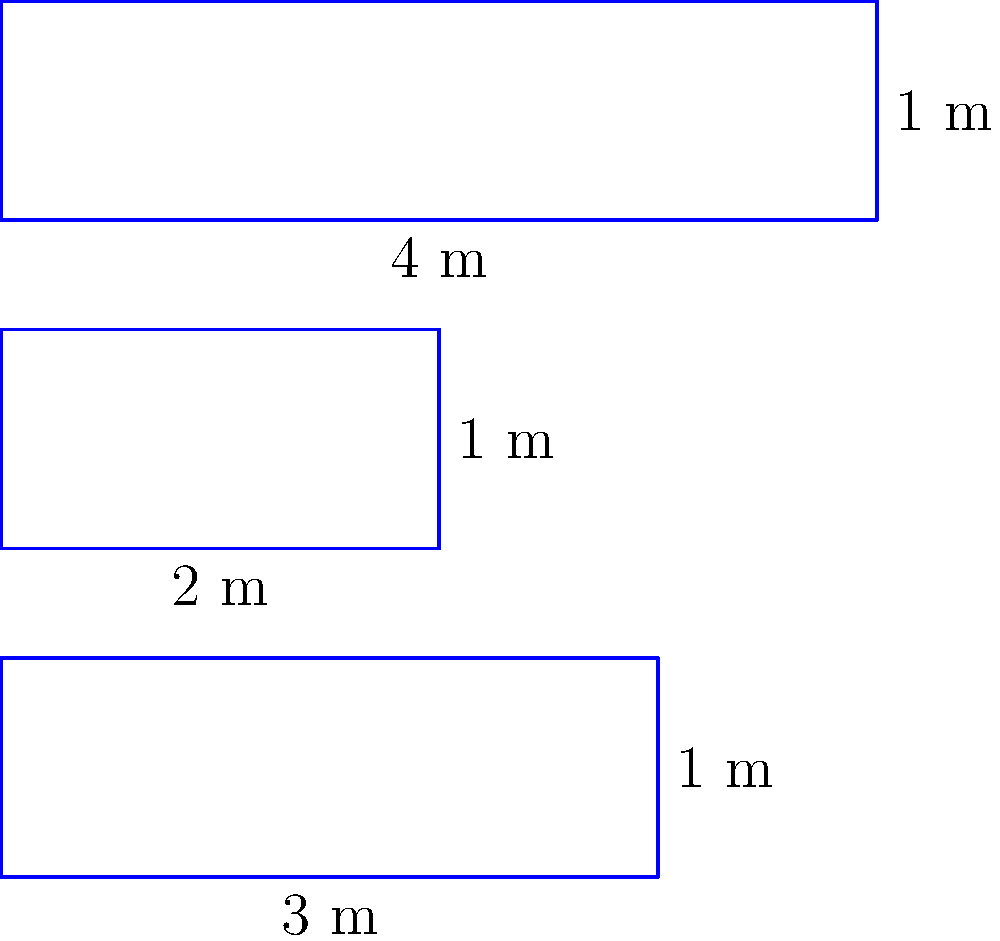As a personal shopper, you're redesigning a shoe display at a discount store. You have three rectangular shelves with different dimensions as shown in the diagram. Calculate the total area of all three shelves combined. Express your answer in square meters. To find the total area of the three rectangular shelves, we need to:

1. Calculate the area of each shelf
2. Sum up the areas

Let's go through it step-by-step:

1. Area of bottom shelf:
   Length = 3 m, Width = 1 m
   Area = $3 \times 1 = 3$ m²

2. Area of middle shelf:
   Length = 2 m, Width = 1 m
   Area = $2 \times 1 = 2$ m²

3. Area of top shelf:
   Length = 4 m, Width = 1 m
   Area = $4 \times 1 = 4$ m²

4. Total area:
   $\text{Total Area} = 3 \text{ m}^2 + 2 \text{ m}^2 + 4 \text{ m}^2 = 9 \text{ m}^2$

Therefore, the total area of all three shelves combined is 9 square meters.
Answer: $9 \text{ m}^2$ 